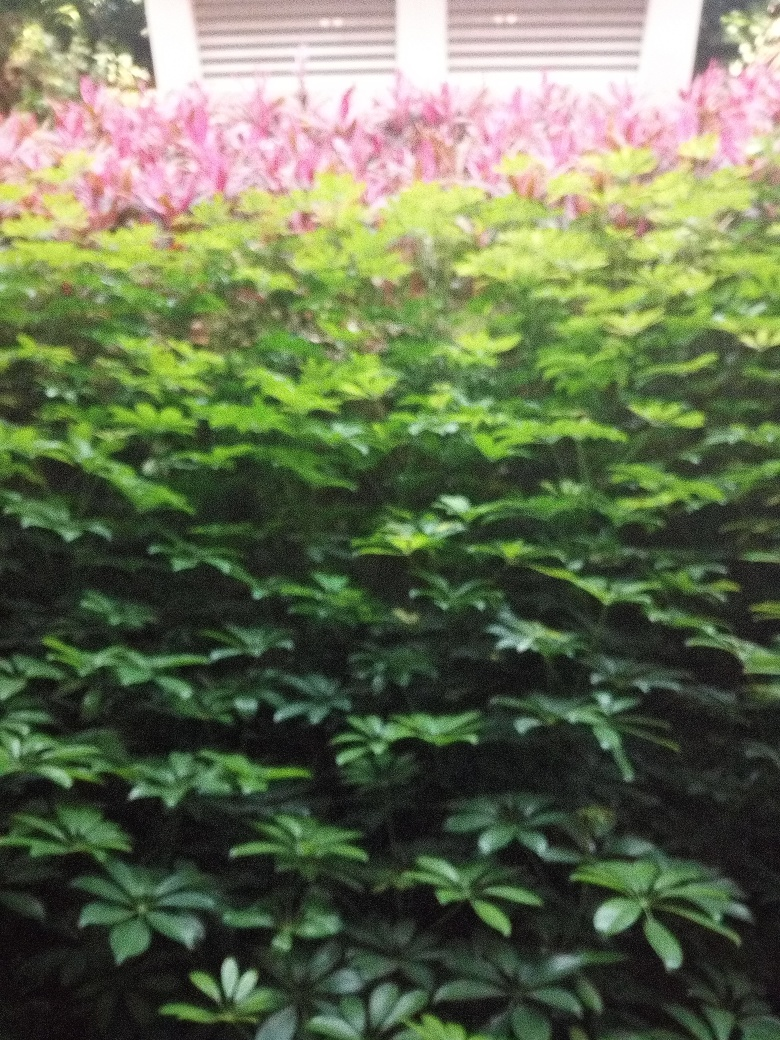What time of day do you think this photo was taken? Given the muted lighting and lack of strong shadows, it seems plausible that the photo was taken during the early evening or on an overcast day, which also may have contributed to the graininess of the image. 